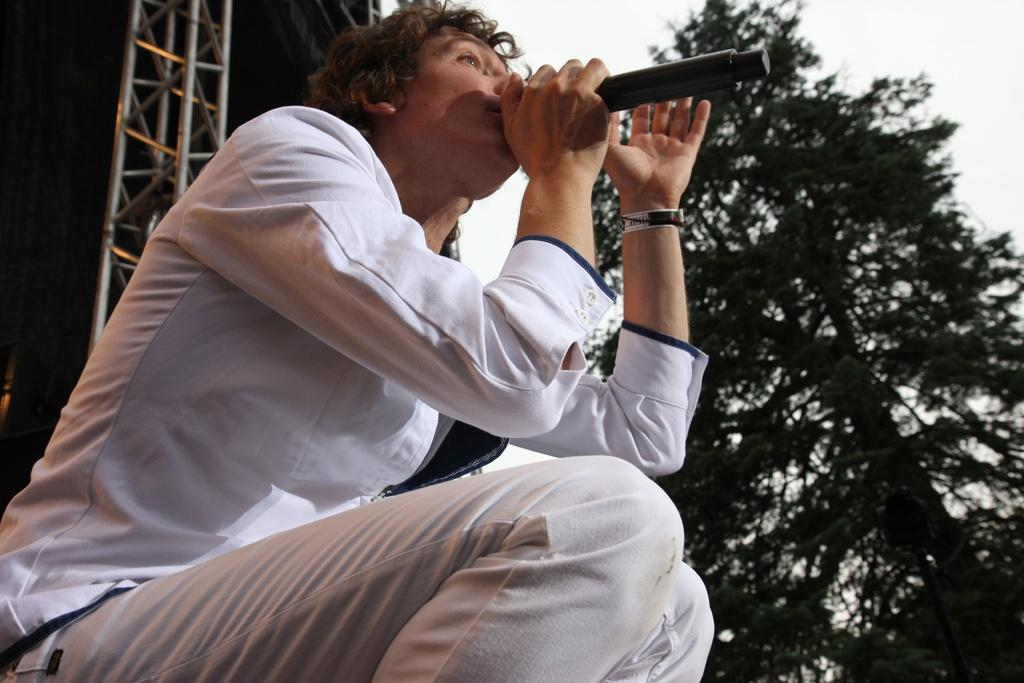Who is the main subject in the image? There is a boy in the center of the image. What is the boy holding in his hand? The boy is holding a mic in his hand. What can be seen in the background of the image? There is a tower and a tree in the background of the image. What is the temperature like in the park shown in the image? There is no park present in the image, and therefore no information about the temperature can be provided. 